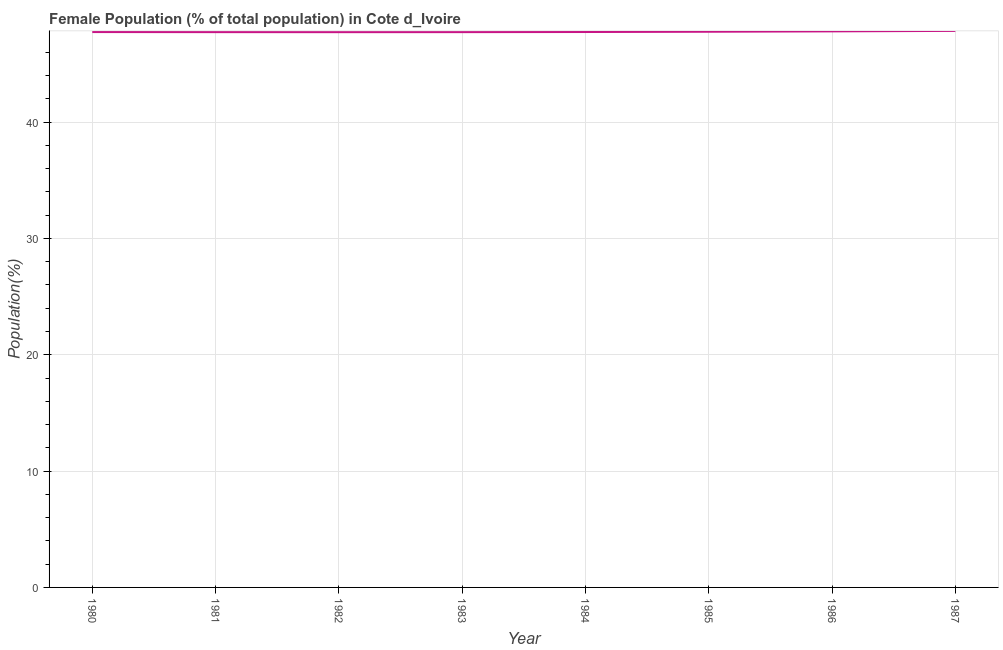What is the female population in 1987?
Give a very brief answer. 47.84. Across all years, what is the maximum female population?
Offer a terse response. 47.84. Across all years, what is the minimum female population?
Your response must be concise. 47.73. In which year was the female population maximum?
Give a very brief answer. 1987. What is the sum of the female population?
Keep it short and to the point. 382.1. What is the difference between the female population in 1980 and 1984?
Make the answer very short. -0. What is the average female population per year?
Your answer should be very brief. 47.76. What is the median female population?
Keep it short and to the point. 47.74. Do a majority of the years between 1982 and 1980 (inclusive) have female population greater than 24 %?
Keep it short and to the point. No. What is the ratio of the female population in 1983 to that in 1984?
Give a very brief answer. 1. Is the female population in 1981 less than that in 1987?
Ensure brevity in your answer.  Yes. What is the difference between the highest and the second highest female population?
Offer a very short reply. 0.04. What is the difference between the highest and the lowest female population?
Your answer should be compact. 0.11. In how many years, is the female population greater than the average female population taken over all years?
Make the answer very short. 3. Does the female population monotonically increase over the years?
Offer a very short reply. No. How many lines are there?
Offer a very short reply. 1. Does the graph contain any zero values?
Your answer should be compact. No. What is the title of the graph?
Provide a short and direct response. Female Population (% of total population) in Cote d_Ivoire. What is the label or title of the X-axis?
Make the answer very short. Year. What is the label or title of the Y-axis?
Provide a short and direct response. Population(%). What is the Population(%) in 1980?
Give a very brief answer. 47.74. What is the Population(%) in 1981?
Ensure brevity in your answer.  47.73. What is the Population(%) in 1982?
Your response must be concise. 47.73. What is the Population(%) in 1983?
Offer a very short reply. 47.73. What is the Population(%) in 1984?
Your answer should be very brief. 47.75. What is the Population(%) of 1985?
Keep it short and to the point. 47.77. What is the Population(%) in 1986?
Your response must be concise. 47.8. What is the Population(%) in 1987?
Ensure brevity in your answer.  47.84. What is the difference between the Population(%) in 1980 and 1981?
Provide a short and direct response. 0.01. What is the difference between the Population(%) in 1980 and 1982?
Your response must be concise. 0.01. What is the difference between the Population(%) in 1980 and 1983?
Your response must be concise. 0.01. What is the difference between the Population(%) in 1980 and 1984?
Offer a very short reply. -0. What is the difference between the Population(%) in 1980 and 1985?
Your answer should be compact. -0.03. What is the difference between the Population(%) in 1980 and 1986?
Offer a terse response. -0.06. What is the difference between the Population(%) in 1980 and 1987?
Your answer should be compact. -0.1. What is the difference between the Population(%) in 1981 and 1982?
Your answer should be compact. 0. What is the difference between the Population(%) in 1981 and 1983?
Keep it short and to the point. 0. What is the difference between the Population(%) in 1981 and 1984?
Give a very brief answer. -0.01. What is the difference between the Population(%) in 1981 and 1985?
Your response must be concise. -0.03. What is the difference between the Population(%) in 1981 and 1986?
Make the answer very short. -0.07. What is the difference between the Population(%) in 1981 and 1987?
Provide a short and direct response. -0.11. What is the difference between the Population(%) in 1982 and 1983?
Ensure brevity in your answer.  -0. What is the difference between the Population(%) in 1982 and 1984?
Your response must be concise. -0.01. What is the difference between the Population(%) in 1982 and 1985?
Make the answer very short. -0.04. What is the difference between the Population(%) in 1982 and 1986?
Give a very brief answer. -0.07. What is the difference between the Population(%) in 1982 and 1987?
Keep it short and to the point. -0.11. What is the difference between the Population(%) in 1983 and 1984?
Give a very brief answer. -0.01. What is the difference between the Population(%) in 1983 and 1985?
Your answer should be very brief. -0.03. What is the difference between the Population(%) in 1983 and 1986?
Provide a short and direct response. -0.07. What is the difference between the Population(%) in 1983 and 1987?
Offer a very short reply. -0.11. What is the difference between the Population(%) in 1984 and 1985?
Your answer should be very brief. -0.02. What is the difference between the Population(%) in 1984 and 1986?
Your answer should be compact. -0.06. What is the difference between the Population(%) in 1984 and 1987?
Your answer should be compact. -0.1. What is the difference between the Population(%) in 1985 and 1986?
Offer a terse response. -0.03. What is the difference between the Population(%) in 1985 and 1987?
Offer a very short reply. -0.07. What is the difference between the Population(%) in 1986 and 1987?
Keep it short and to the point. -0.04. What is the ratio of the Population(%) in 1980 to that in 1982?
Offer a very short reply. 1. What is the ratio of the Population(%) in 1980 to that in 1987?
Make the answer very short. 1. What is the ratio of the Population(%) in 1981 to that in 1986?
Provide a succinct answer. 1. What is the ratio of the Population(%) in 1981 to that in 1987?
Provide a short and direct response. 1. What is the ratio of the Population(%) in 1982 to that in 1983?
Give a very brief answer. 1. What is the ratio of the Population(%) in 1982 to that in 1987?
Provide a short and direct response. 1. What is the ratio of the Population(%) in 1983 to that in 1984?
Give a very brief answer. 1. What is the ratio of the Population(%) in 1983 to that in 1985?
Ensure brevity in your answer.  1. What is the ratio of the Population(%) in 1983 to that in 1986?
Make the answer very short. 1. What is the ratio of the Population(%) in 1984 to that in 1985?
Your answer should be compact. 1. What is the ratio of the Population(%) in 1984 to that in 1987?
Provide a succinct answer. 1. What is the ratio of the Population(%) in 1985 to that in 1987?
Provide a short and direct response. 1. What is the ratio of the Population(%) in 1986 to that in 1987?
Your answer should be very brief. 1. 